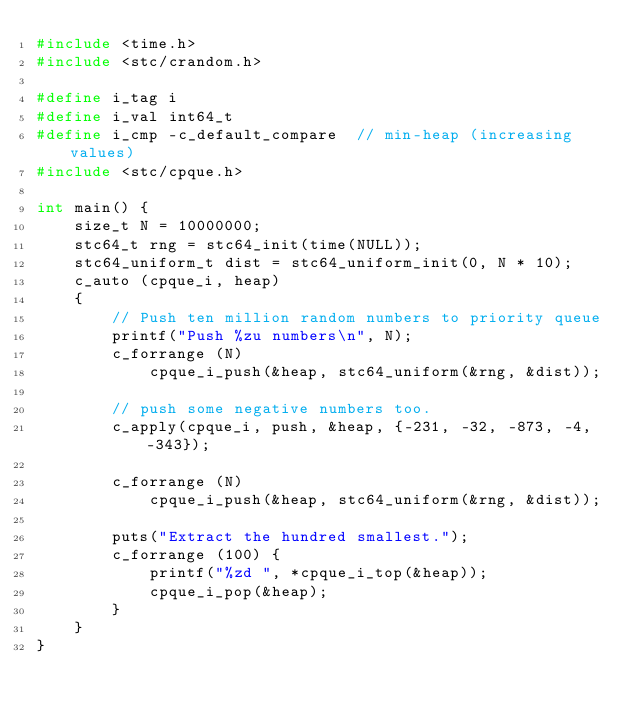Convert code to text. <code><loc_0><loc_0><loc_500><loc_500><_C_>#include <time.h>
#include <stc/crandom.h>

#define i_tag i
#define i_val int64_t
#define i_cmp -c_default_compare  // min-heap (increasing values)
#include <stc/cpque.h>

int main() {
    size_t N = 10000000;
    stc64_t rng = stc64_init(time(NULL));
    stc64_uniform_t dist = stc64_uniform_init(0, N * 10);
    c_auto (cpque_i, heap)
    {
        // Push ten million random numbers to priority queue
        printf("Push %zu numbers\n", N);
        c_forrange (N)
            cpque_i_push(&heap, stc64_uniform(&rng, &dist));

        // push some negative numbers too.
        c_apply(cpque_i, push, &heap, {-231, -32, -873, -4, -343});

        c_forrange (N)
            cpque_i_push(&heap, stc64_uniform(&rng, &dist));

        puts("Extract the hundred smallest.");
        c_forrange (100) {
            printf("%zd ", *cpque_i_top(&heap));
            cpque_i_pop(&heap);
        }
    }
}
</code> 